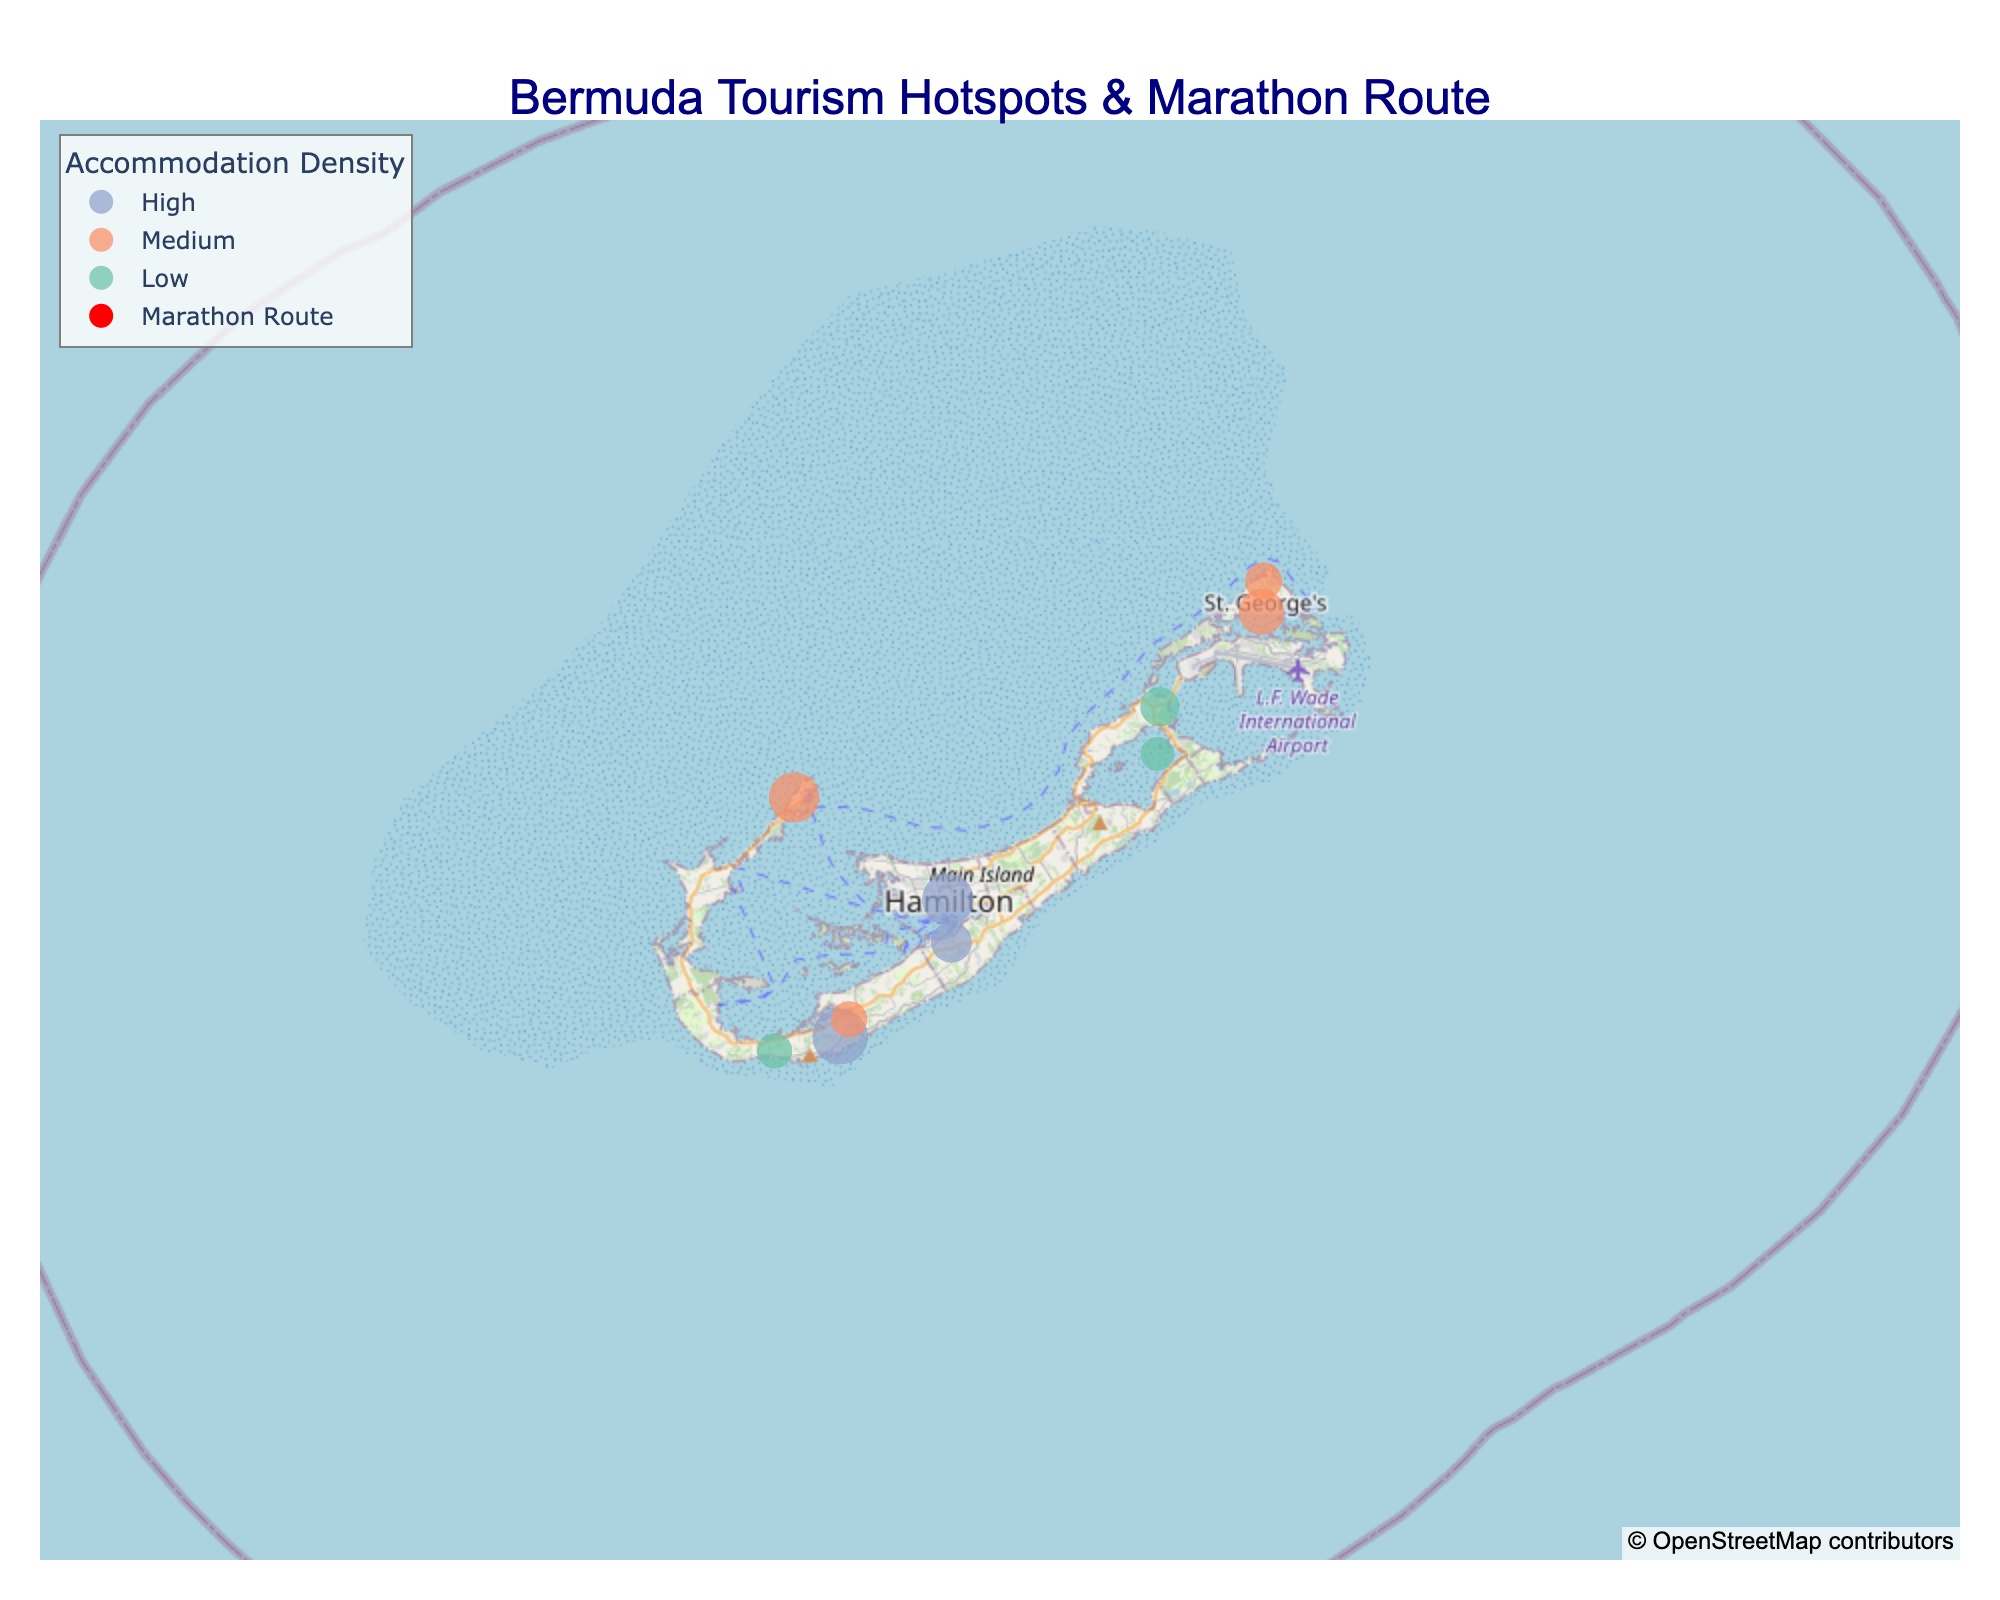What's the title of the map? The title is written at the top center of the map, indicated by larger text in a navy color. The content of the title gives a contextual overview of what the map illustrates.
Answer: Bermuda Tourism Hotspots & Marathon Route Which attraction has the highest visitor footfall? Visitor footfall is represented by the size of the markers on the map. The largest marker corresponds to the attraction with the highest visitor footfall.
Answer: Horseshoe Bay Beach How many attractions are located on the marathon route? Look for red markers with a running symbol, which indicate the attractions on the marathon route. Counting these markers gives the answer.
Answer: 6 What is the accommodation density around the Royal Naval Dockyard? The marker color represents accommodation density. Refer to the legend to identify the color corresponding to the Royal Naval Dockyard's marker, then match it to its description in the legend.
Answer: Medium Which attraction has the lowest visitor footfall on the marathon route? Filter out attractions not on the marathon route by focusing on the red markers. Among these red markers, identify the smallest marker, which indicates the lowest visitor footfall.
Answer: Gibbs Hill Lighthouse What are the three attractions with medium accommodation density? Medium accommodation density is indicated by a specific color. By identifying all markers of this color, you can list the names of the corresponding attractions.
Answer: Royal Naval Dockyard, St. George's, Tobacco Bay Beach, Warwick Long Bay Which marathon route attraction has the highest visitor footfall? Among the attractions on the marathon route (indicated by red markers), find the largest marker to determine which one has the highest visitor footfall.
Answer: Horseshoe Bay Beach Compare the visitor footfall of Crystal Caves and Bermuda Aquarium. Which one is greater? Look at the sizes of the markers for Crystal Caves and Bermuda Aquarium. The larger marker represents the attraction with greater visitor footfall.
Answer: Crystal Caves 